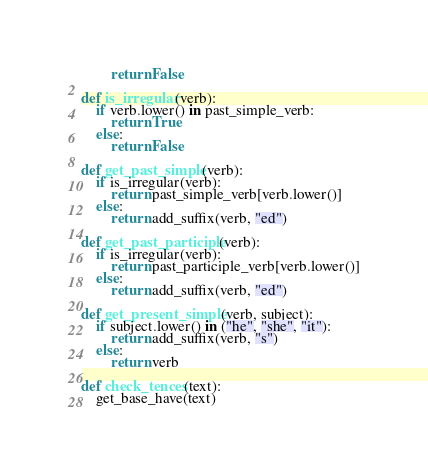<code> <loc_0><loc_0><loc_500><loc_500><_Python_>		return False

def is_irregular(verb):
	if verb.lower() in past_simple_verb:
		return True
	else:
		return False

def get_past_simple(verb):
	if is_irregular(verb):
		return past_simple_verb[verb.lower()]
	else:
		return add_suffix(verb, "ed")

def get_past_participle(verb):
	if is_irregular(verb):
		return past_participle_verb[verb.lower()]
	else:
		return add_suffix(verb, "ed")

def get_present_simple(verb, subject):
	if subject.lower() in ("he", "she", "it"):
		return add_suffix(verb, "s")
	else:
		return verb

def check_tences(text):
	get_base_have(text)

</code> 